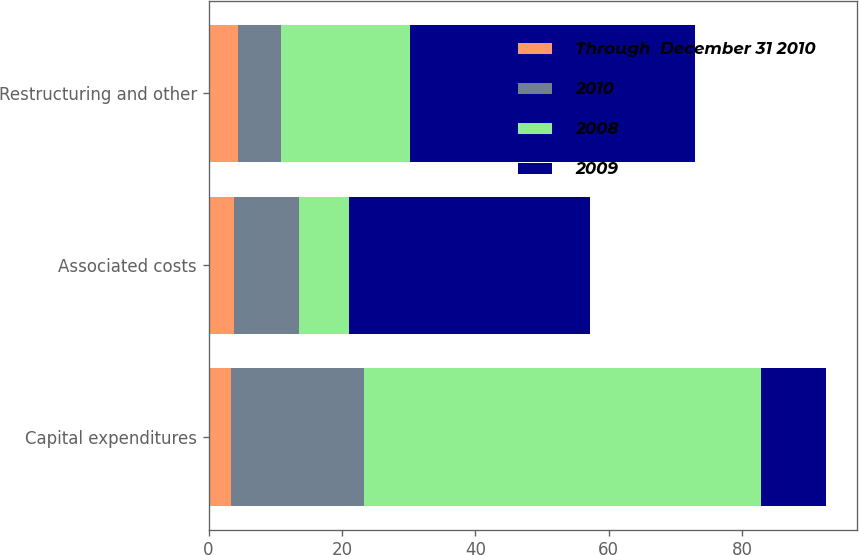Convert chart to OTSL. <chart><loc_0><loc_0><loc_500><loc_500><stacked_bar_chart><ecel><fcel>Capital expenditures<fcel>Associated costs<fcel>Restructuring and other<nl><fcel>Through  December 31 2010<fcel>3.3<fcel>3.8<fcel>4.4<nl><fcel>2010<fcel>20<fcel>9.8<fcel>6.5<nl><fcel>2008<fcel>59.5<fcel>7.4<fcel>19.3<nl><fcel>2009<fcel>9.8<fcel>36.2<fcel>42.7<nl></chart> 